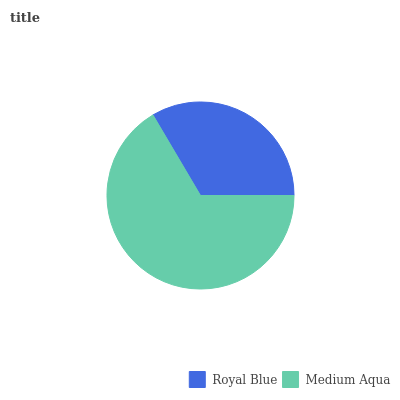Is Royal Blue the minimum?
Answer yes or no. Yes. Is Medium Aqua the maximum?
Answer yes or no. Yes. Is Medium Aqua the minimum?
Answer yes or no. No. Is Medium Aqua greater than Royal Blue?
Answer yes or no. Yes. Is Royal Blue less than Medium Aqua?
Answer yes or no. Yes. Is Royal Blue greater than Medium Aqua?
Answer yes or no. No. Is Medium Aqua less than Royal Blue?
Answer yes or no. No. Is Medium Aqua the high median?
Answer yes or no. Yes. Is Royal Blue the low median?
Answer yes or no. Yes. Is Royal Blue the high median?
Answer yes or no. No. Is Medium Aqua the low median?
Answer yes or no. No. 